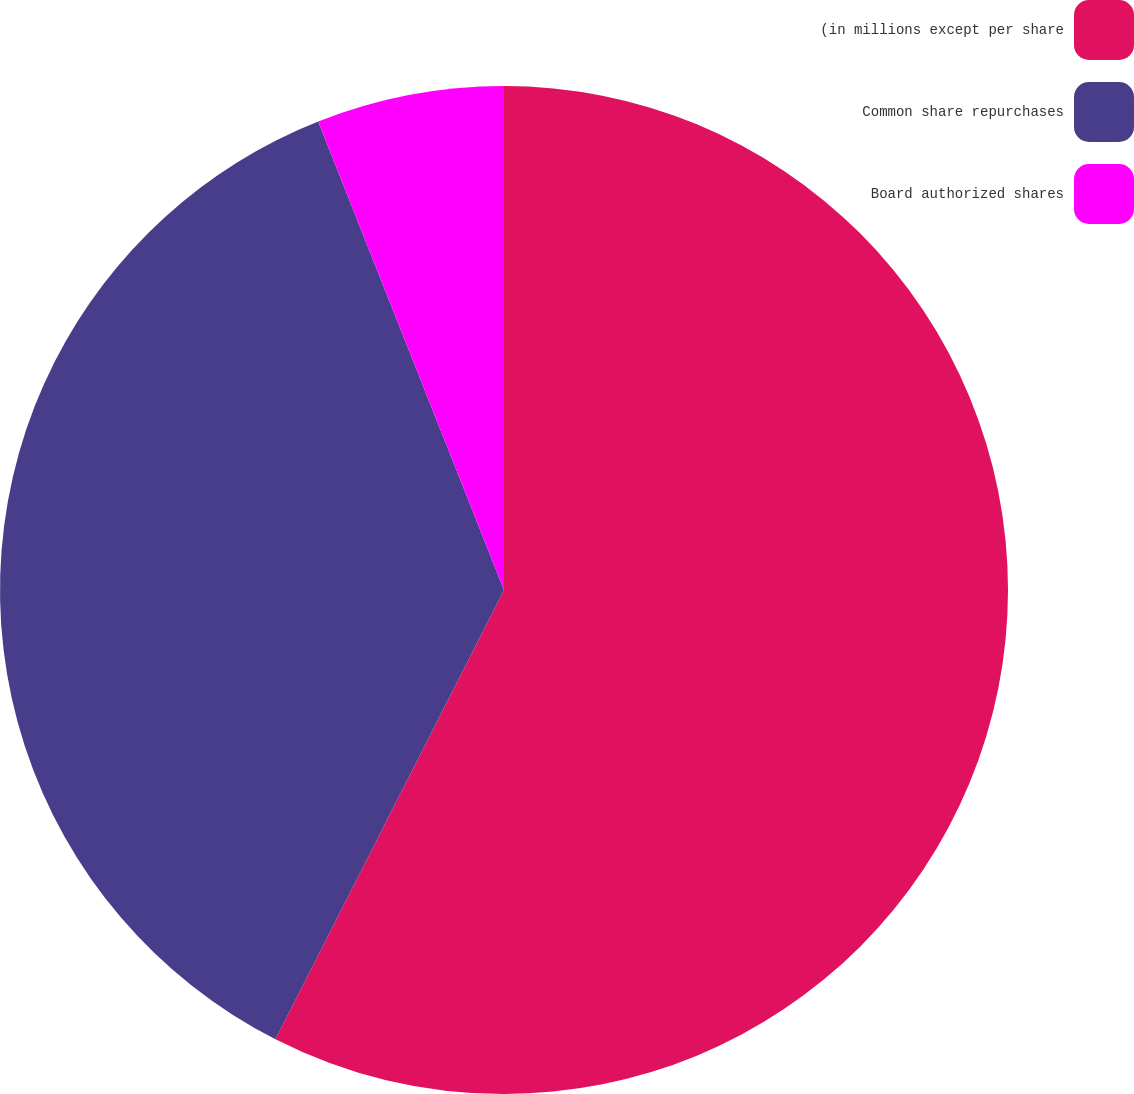Convert chart. <chart><loc_0><loc_0><loc_500><loc_500><pie_chart><fcel>(in millions except per share<fcel>Common share repurchases<fcel>Board authorized shares<nl><fcel>57.49%<fcel>36.5%<fcel>6.01%<nl></chart> 